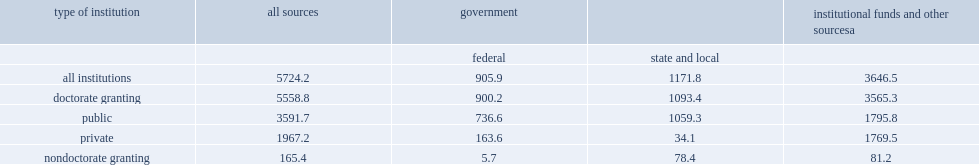Twenty-two percent of the nation's 570 research-performing colleges and universities (126 institutions) initiated new construction of s&e research space in fys 2014-15, what was the estimated completion costs? 5.7. How many million dollars of federal support is the most since data collection began in fys 1986-87? 905.9. 